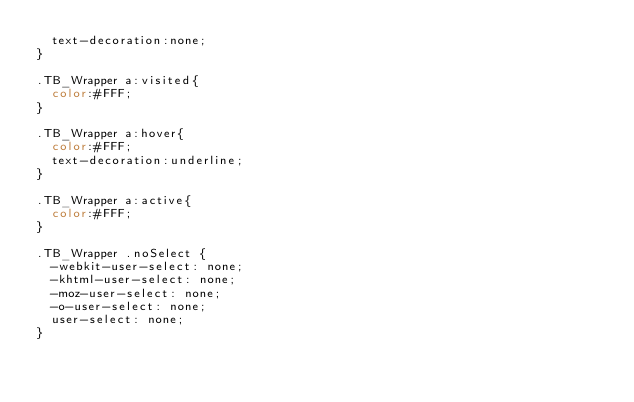<code> <loc_0><loc_0><loc_500><loc_500><_CSS_>	text-decoration:none;
}
	
.TB_Wrapper a:visited{		
	color:#FFF;
}
	
.TB_Wrapper a:hover{		
	color:#FFF;
	text-decoration:underline;
}
	
.TB_Wrapper a:active{		
	color:#FFF;
}

.TB_Wrapper .noSelect {
	-webkit-user-select: none;
	-khtml-user-select: none;
	-moz-user-select: none;
	-o-user-select: none;
	user-select: none;
}</code> 